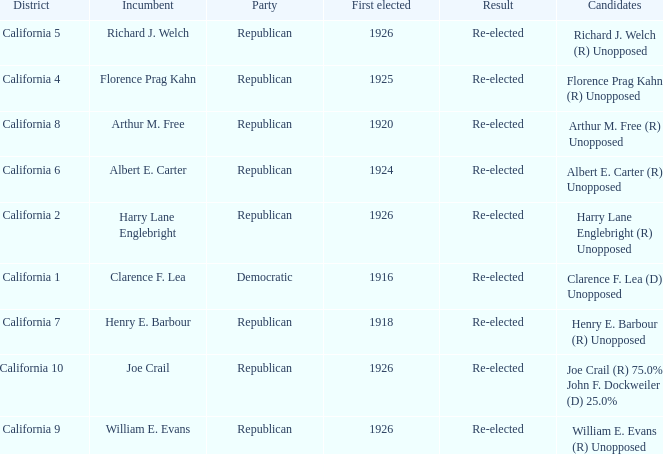What's the party with incumbent being william e. evans Republican. 